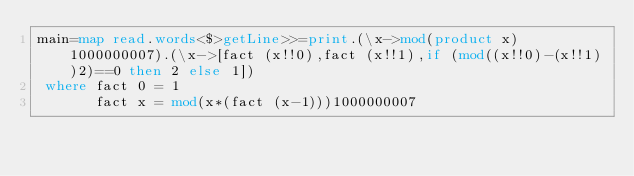<code> <loc_0><loc_0><loc_500><loc_500><_Haskell_>main=map read.words<$>getLine>>=print.(\x->mod(product x)1000000007).(\x->[fact (x!!0),fact (x!!1),if (mod((x!!0)-(x!!1))2)==0 then 2 else 1])
 where fact 0 = 1
       fact x = mod(x*(fact (x-1)))1000000007</code> 